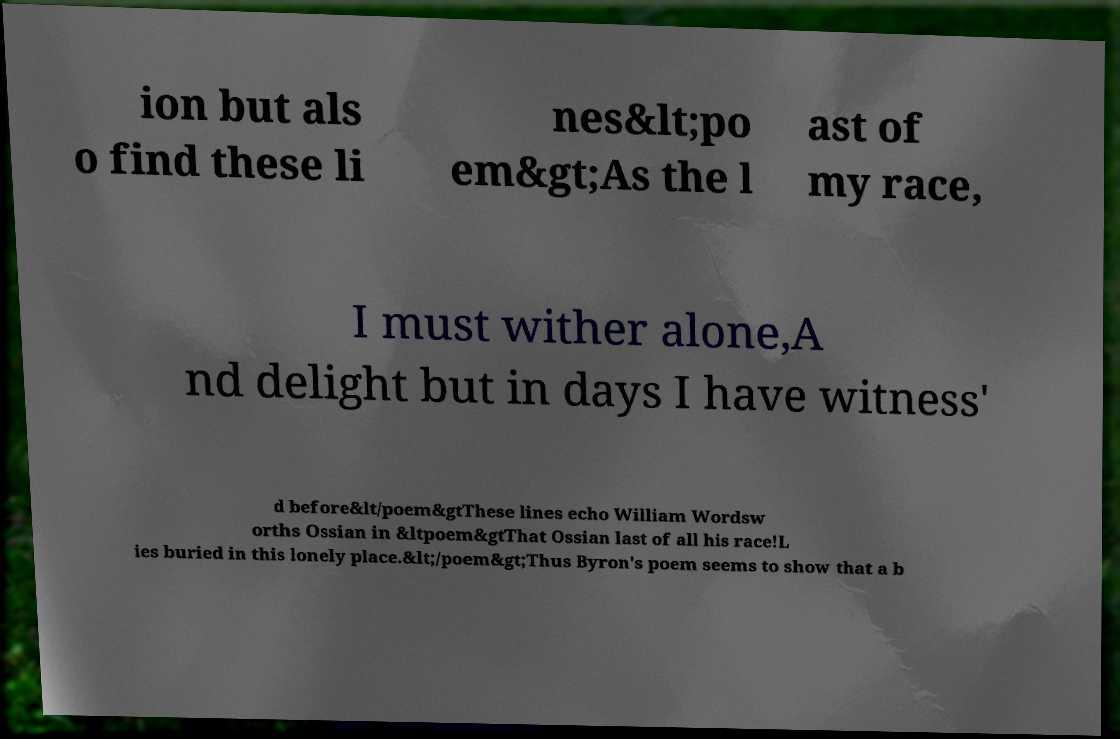There's text embedded in this image that I need extracted. Can you transcribe it verbatim? ion but als o find these li nes&lt;po em&gt;As the l ast of my race, I must wither alone,A nd delight but in days I have witness' d before&lt/poem&gtThese lines echo William Wordsw orths Ossian in &ltpoem&gtThat Ossian last of all his race!L ies buried in this lonely place.&lt;/poem&gt;Thus Byron's poem seems to show that a b 